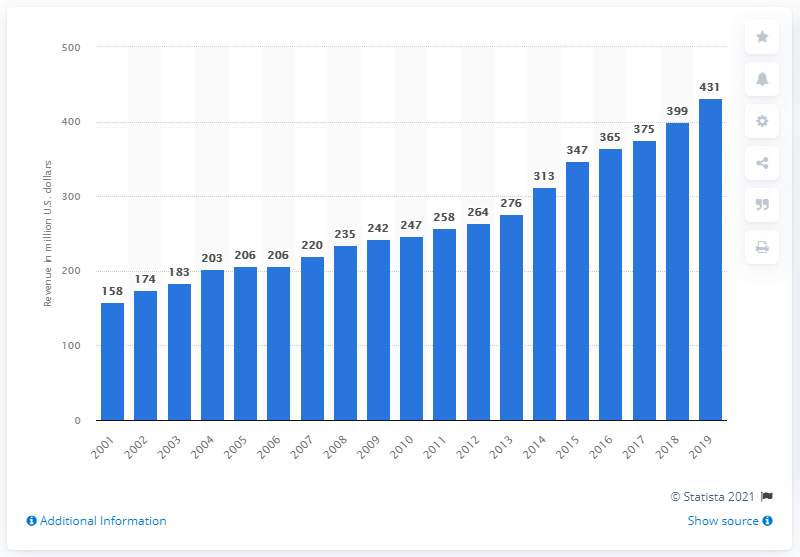Draw attention to some important aspects in this diagram. The revenue of the Cleveland Browns in 2019 was 431 million dollars. 